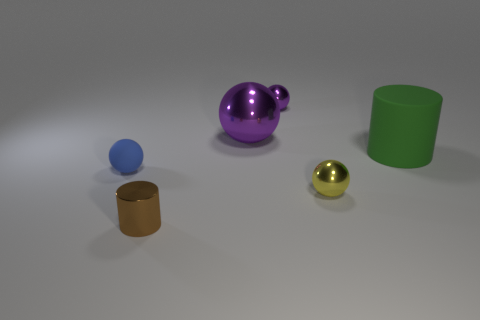Subtract all small balls. How many balls are left? 1 Subtract all yellow spheres. How many spheres are left? 3 Subtract 1 spheres. How many spheres are left? 3 Add 2 small cyan matte objects. How many objects exist? 8 Subtract all spheres. How many objects are left? 2 Subtract 0 gray cylinders. How many objects are left? 6 Subtract all red cylinders. Subtract all red balls. How many cylinders are left? 2 Subtract all yellow spheres. How many green cylinders are left? 1 Subtract all large cyan balls. Subtract all tiny yellow spheres. How many objects are left? 5 Add 6 big cylinders. How many big cylinders are left? 7 